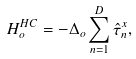<formula> <loc_0><loc_0><loc_500><loc_500>H _ { o } ^ { H C } = - \Delta _ { o } \sum _ { n = 1 } ^ { D } \hat { \tau } ^ { x } _ { n } ,</formula> 